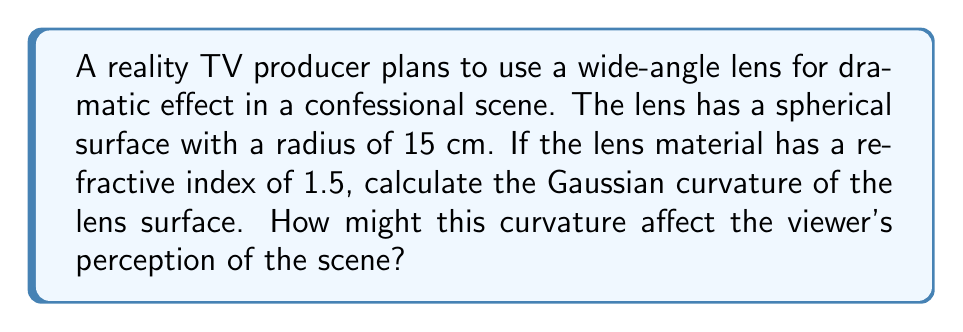Help me with this question. To solve this problem, we'll follow these steps:

1) The Gaussian curvature (K) of a spherical surface is given by:

   $$K = \frac{1}{R^2}$$

   where R is the radius of the sphere.

2) We're given that the radius of the lens surface is 15 cm. Let's substitute this into our equation:

   $$K = \frac{1}{(15 \text{ cm})^2} = \frac{1}{225 \text{ cm}^2}$$

3) Simplifying:

   $$K = 0.004444... \text{ cm}^{-2}$$

4) To understand how this affects the viewer's perception:

   a) The Gaussian curvature is positive, indicating a convex surface.
   
   b) This curvature will cause the image to appear distorted, with objects near the edges of the frame appearing larger and more curved than those in the center.
   
   c) The refractive index of 1.5 will further magnify this effect, as it determines how much the light bends when passing through the lens.

5) In the context of reality TV:

   This curvature could be used to subtly exaggerate facial features or body language of contestants during confessional scenes, potentially heightening the drama for viewers. However, it's important to note that such distortions might raise ethical questions about accurate representation in reality TV.
Answer: $K = 0.004444 \text{ cm}^{-2}$; enhances dramatic effect through subtle distortion 